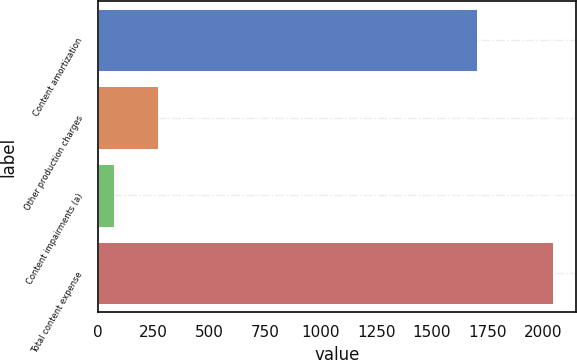<chart> <loc_0><loc_0><loc_500><loc_500><bar_chart><fcel>Content amortization<fcel>Other production charges<fcel>Content impairments (a)<fcel>Total content expense<nl><fcel>1701<fcel>272<fcel>72<fcel>2045<nl></chart> 